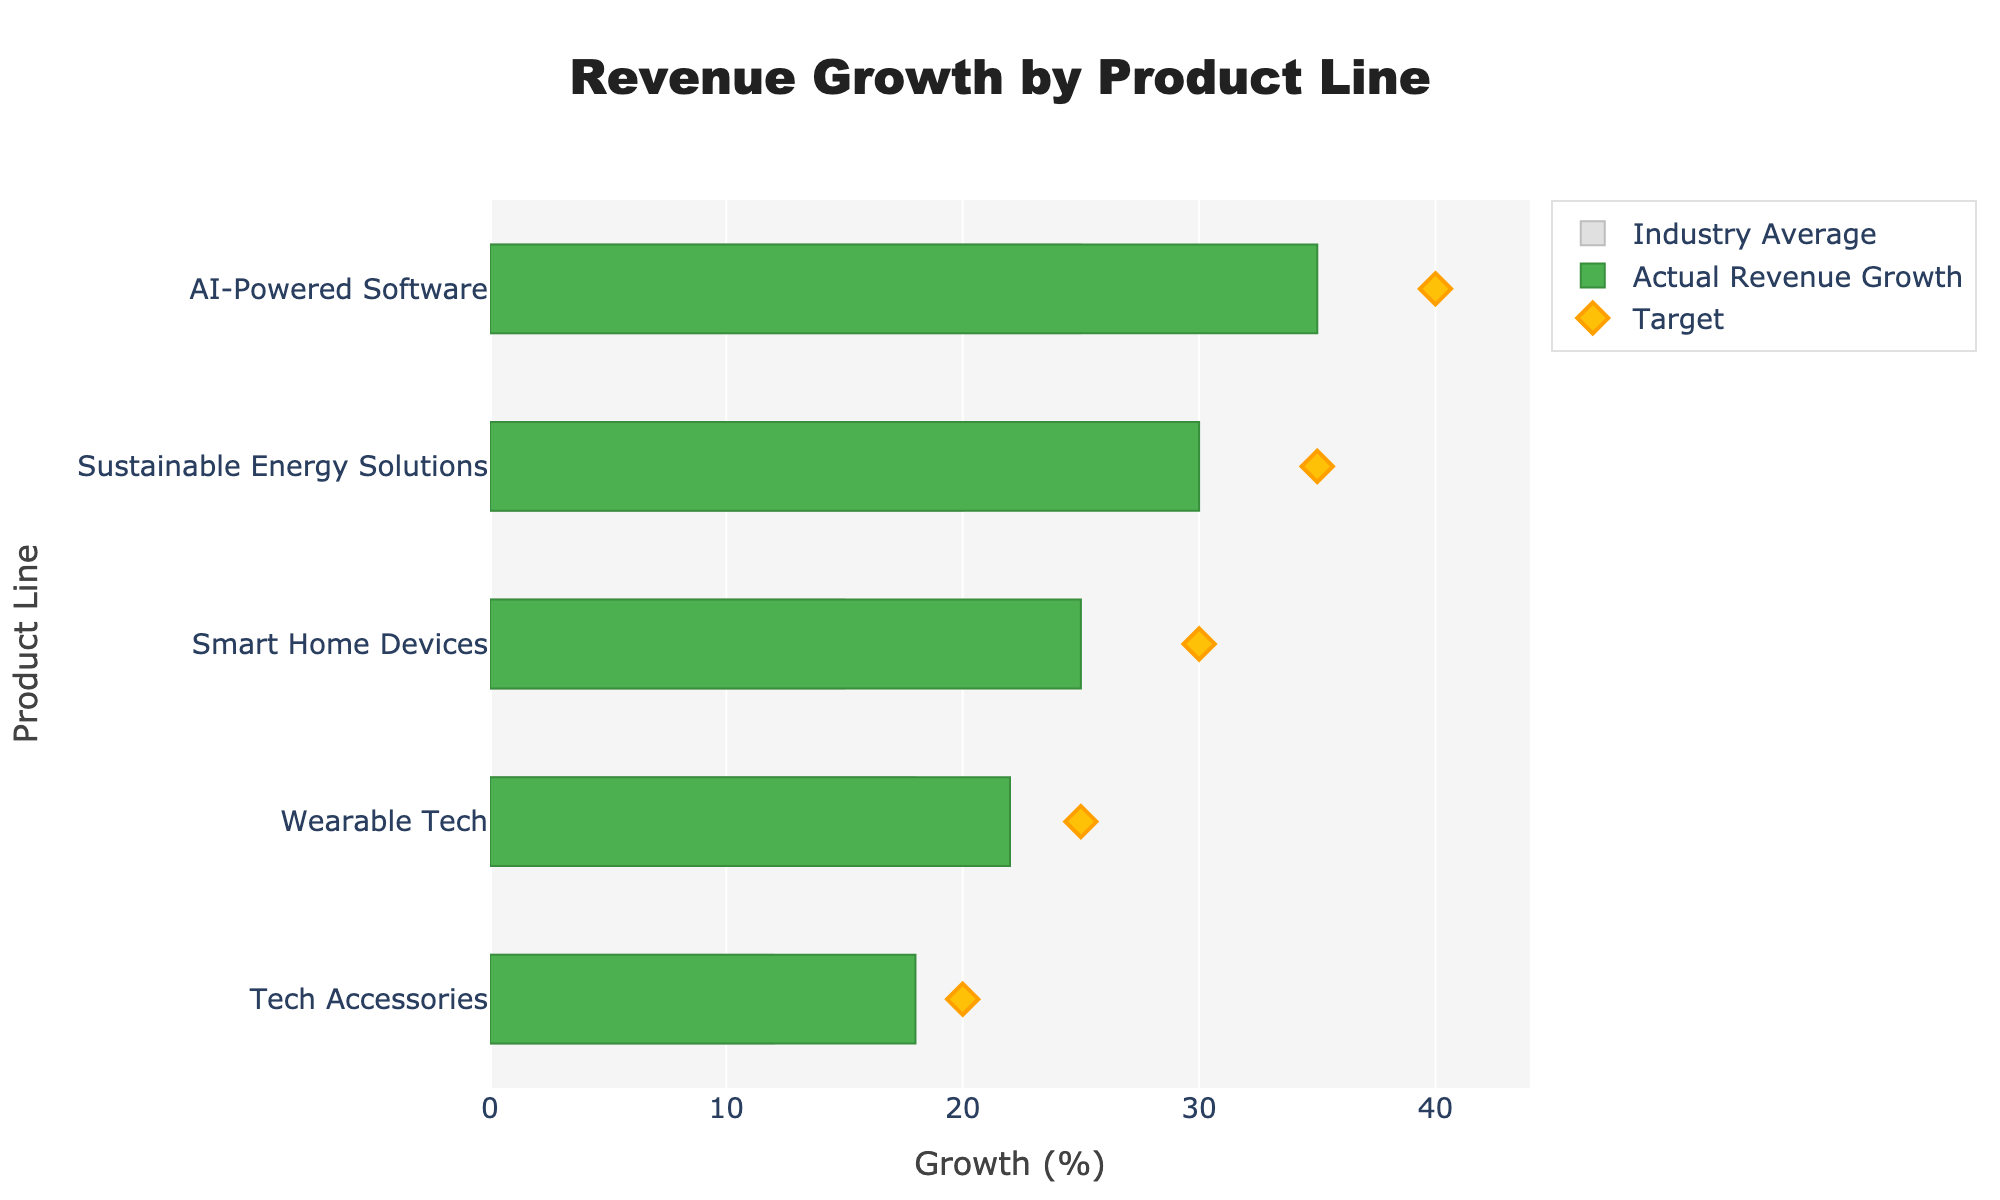What's the title of the chart? The title is typically shown at the top of the chart. Looking at the top of the figure, the title is "Revenue Growth by Product Line."
Answer: Revenue Growth by Product Line What is the product line with the highest actual revenue growth? To find this information, look for the longest green bar, which represents actual revenue growth. The longest green bar is for "AI-Powered Software."
Answer: AI-Powered Software Which product line has the smallest gap between its actual revenue growth and the industry average? Calculate the difference between the green bar (actual) and the gray bar (industry average) for each product line. "Wearable Tech" has the smallest gap, as its actual growth (22%) is only 4% higher than the industry average (18%).
Answer: Wearable Tech Which product line has the actual revenue growth that is closest to its target? Look for the green bar (actual) and the yellow diamond (target) that are the closest. For "Wearable Tech," the actual growth (22%) is closest to the target (25%).
Answer: Wearable Tech How many product lines have an actual revenue growth rate exceeding 25%? Count the green bars that stretch beyond the 25% mark on the x-axis. "Sustainable Energy Solutions" and "AI-Powered Software" both exceed 25%, so there are two product lines including "Smart Home Devices" which is exactly at 25%.
Answer: 3 Among those product lines that did not meet their target, which one has the smallest shortfall from its target? Compare the differences between actual growth and target for the product lines below their target. "Tech Accessories" has an actual growth of 18% and a target of 20%, making the shortfall 2%.
Answer: Tech Accessories What is the difference in actual revenue growth between the highest and lowest product lines? The highest actual revenue growth is "AI-Powered Software" at 35%, and the lowest is "Tech Accessories" at 18%. The difference is 35% - 18% = 17%.
Answer: 17% Which product line is closest to the industry average? Compare the green bars (actual revenue growth) to the gray bars (industry average) and see which pair is most similar. For "Wearable Tech," actual growth (22%) is closest to the industry average (18%).
Answer: Wearable Tech What is the industry average growth rate for "Sustainable Energy Solutions"? Find the gray bar for "Sustainable Energy Solutions" and read its value on the x-axis. The industry average growth rate for this product line is 20%.
Answer: 20% 